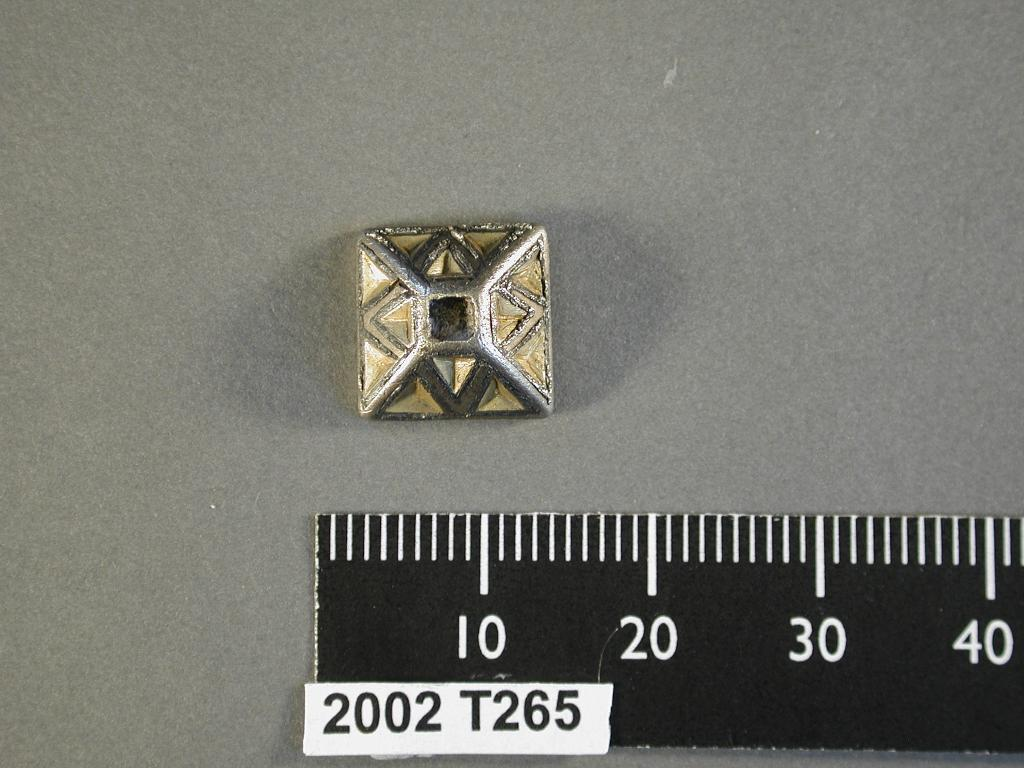<image>
Summarize the visual content of the image. A piece of jewlery around 10 centimeters long. 